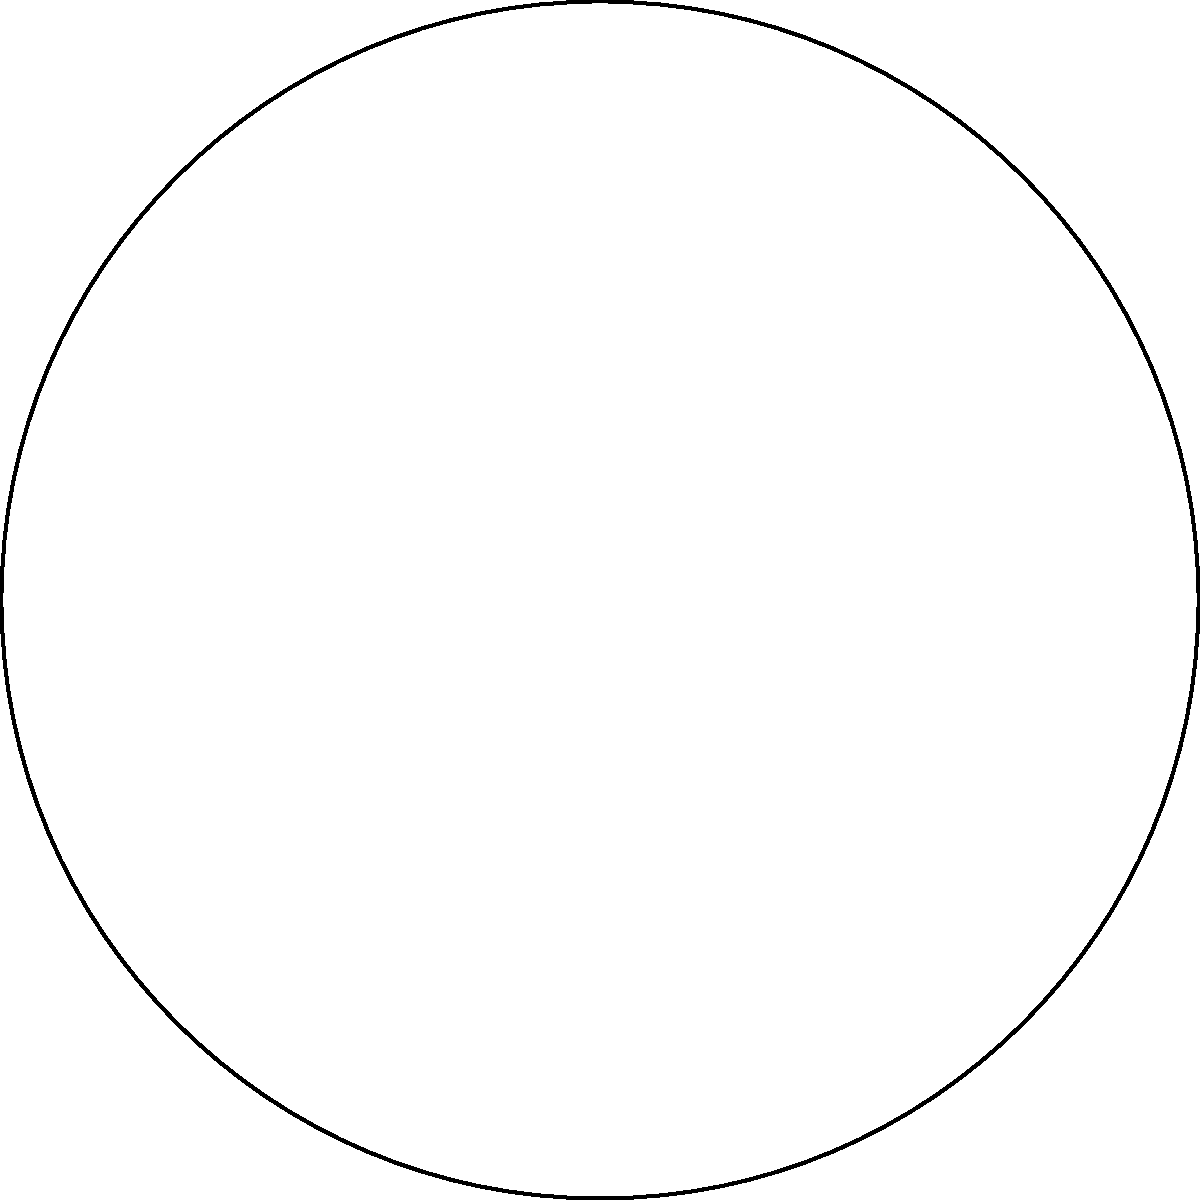As a freelance writer working on a project about circular structures in architecture, you come across an interesting problem. In a circular atrium, an arc spans a central angle of $\theta$ radians and has a length of 15 meters. If this arc represents $\frac{5}{12}$ of the entire circumference, what is the radius of the atrium to the nearest tenth of a meter? Let's approach this step-by-step:

1) First, recall the formula for arc length: $s = r\theta$, where $s$ is the arc length, $r$ is the radius, and $\theta$ is the central angle in radians.

2) We're given that the arc length $s = 15$ meters and that this represents $\frac{5}{12}$ of the circumference.

3) The full circumference of a circle is given by $2\pi r$. So we can write:

   $15 = \frac{5}{12}(2\pi r)$

4) Let's solve this equation for $r$:

   $15 = \frac{5\pi r}{6}$

   $\frac{90}{5\pi} = r$

5) Now, let's calculate this:

   $r = \frac{90}{5\pi} \approx 5.73$ meters

6) Rounding to the nearest tenth, we get 5.7 meters.

This problem illustrates how the proportions of a circle can be used to determine its dimensions, which could be useful in architectural design or in understanding the geometry of existing structures.
Answer: 5.7 meters 